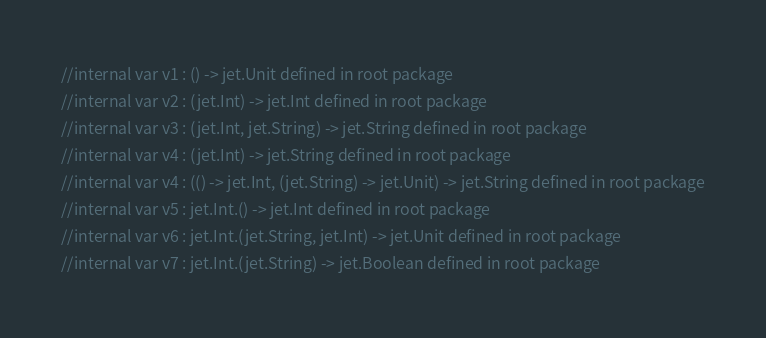Convert code to text. <code><loc_0><loc_0><loc_500><loc_500><_Kotlin_>//internal var v1 : () -> jet.Unit defined in root package
//internal var v2 : (jet.Int) -> jet.Int defined in root package
//internal var v3 : (jet.Int, jet.String) -> jet.String defined in root package
//internal var v4 : (jet.Int) -> jet.String defined in root package
//internal var v4 : (() -> jet.Int, (jet.String) -> jet.Unit) -> jet.String defined in root package
//internal var v5 : jet.Int.() -> jet.Int defined in root package
//internal var v6 : jet.Int.(jet.String, jet.Int) -> jet.Unit defined in root package
//internal var v7 : jet.Int.(jet.String) -> jet.Boolean defined in root package
</code> 